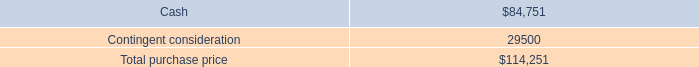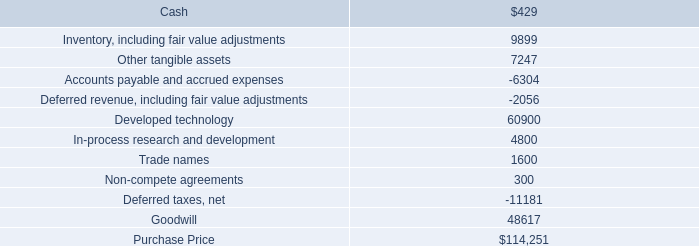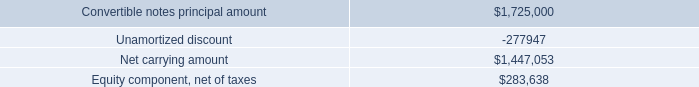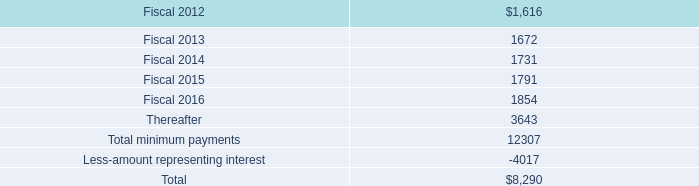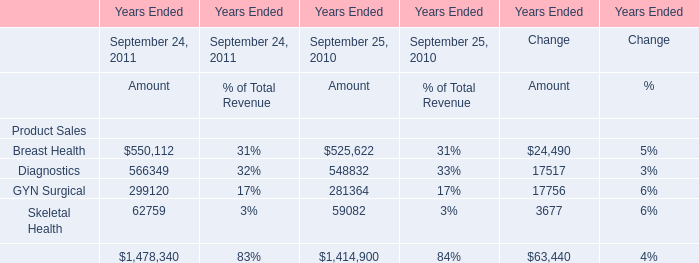What's the total amount of all Revenue for Product Sales that is smaller than 100000 for the year ended September 25, 2010? 
Answer: 59082. 